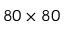<formula> <loc_0><loc_0><loc_500><loc_500>8 0 \times 8 0</formula> 